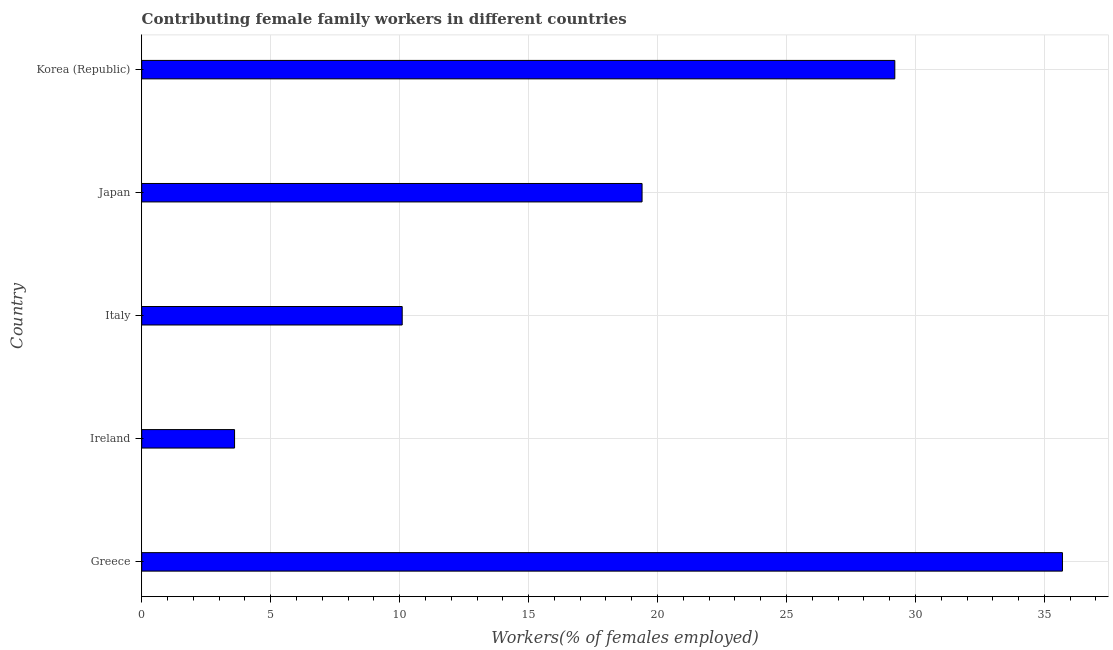Does the graph contain grids?
Your response must be concise. Yes. What is the title of the graph?
Offer a very short reply. Contributing female family workers in different countries. What is the label or title of the X-axis?
Offer a very short reply. Workers(% of females employed). What is the label or title of the Y-axis?
Provide a succinct answer. Country. What is the contributing female family workers in Japan?
Offer a terse response. 19.4. Across all countries, what is the maximum contributing female family workers?
Keep it short and to the point. 35.7. Across all countries, what is the minimum contributing female family workers?
Make the answer very short. 3.6. In which country was the contributing female family workers maximum?
Give a very brief answer. Greece. In which country was the contributing female family workers minimum?
Offer a terse response. Ireland. What is the sum of the contributing female family workers?
Offer a very short reply. 98. What is the difference between the contributing female family workers in Ireland and Korea (Republic)?
Provide a short and direct response. -25.6. What is the average contributing female family workers per country?
Your answer should be compact. 19.6. What is the median contributing female family workers?
Ensure brevity in your answer.  19.4. What is the ratio of the contributing female family workers in Ireland to that in Japan?
Offer a very short reply. 0.19. Is the contributing female family workers in Greece less than that in Italy?
Your answer should be compact. No. What is the difference between the highest and the second highest contributing female family workers?
Offer a very short reply. 6.5. What is the difference between the highest and the lowest contributing female family workers?
Offer a terse response. 32.1. In how many countries, is the contributing female family workers greater than the average contributing female family workers taken over all countries?
Make the answer very short. 2. What is the difference between two consecutive major ticks on the X-axis?
Ensure brevity in your answer.  5. Are the values on the major ticks of X-axis written in scientific E-notation?
Your answer should be compact. No. What is the Workers(% of females employed) of Greece?
Provide a short and direct response. 35.7. What is the Workers(% of females employed) of Ireland?
Make the answer very short. 3.6. What is the Workers(% of females employed) of Italy?
Your answer should be compact. 10.1. What is the Workers(% of females employed) of Japan?
Offer a terse response. 19.4. What is the Workers(% of females employed) of Korea (Republic)?
Your answer should be very brief. 29.2. What is the difference between the Workers(% of females employed) in Greece and Ireland?
Your answer should be compact. 32.1. What is the difference between the Workers(% of females employed) in Greece and Italy?
Provide a short and direct response. 25.6. What is the difference between the Workers(% of females employed) in Greece and Japan?
Your response must be concise. 16.3. What is the difference between the Workers(% of females employed) in Greece and Korea (Republic)?
Your response must be concise. 6.5. What is the difference between the Workers(% of females employed) in Ireland and Japan?
Provide a succinct answer. -15.8. What is the difference between the Workers(% of females employed) in Ireland and Korea (Republic)?
Give a very brief answer. -25.6. What is the difference between the Workers(% of females employed) in Italy and Korea (Republic)?
Your answer should be compact. -19.1. What is the difference between the Workers(% of females employed) in Japan and Korea (Republic)?
Your response must be concise. -9.8. What is the ratio of the Workers(% of females employed) in Greece to that in Ireland?
Provide a succinct answer. 9.92. What is the ratio of the Workers(% of females employed) in Greece to that in Italy?
Provide a succinct answer. 3.54. What is the ratio of the Workers(% of females employed) in Greece to that in Japan?
Your answer should be compact. 1.84. What is the ratio of the Workers(% of females employed) in Greece to that in Korea (Republic)?
Ensure brevity in your answer.  1.22. What is the ratio of the Workers(% of females employed) in Ireland to that in Italy?
Ensure brevity in your answer.  0.36. What is the ratio of the Workers(% of females employed) in Ireland to that in Japan?
Give a very brief answer. 0.19. What is the ratio of the Workers(% of females employed) in Ireland to that in Korea (Republic)?
Your answer should be compact. 0.12. What is the ratio of the Workers(% of females employed) in Italy to that in Japan?
Your answer should be very brief. 0.52. What is the ratio of the Workers(% of females employed) in Italy to that in Korea (Republic)?
Your response must be concise. 0.35. What is the ratio of the Workers(% of females employed) in Japan to that in Korea (Republic)?
Your answer should be very brief. 0.66. 